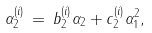Convert formula to latex. <formula><loc_0><loc_0><loc_500><loc_500>\alpha _ { 2 } ^ { ( i ) } \, = \, b _ { 2 } ^ { ( i ) } \alpha _ { 2 } + c _ { 2 } ^ { ( i ) } \alpha _ { 1 } ^ { 2 } ,</formula> 